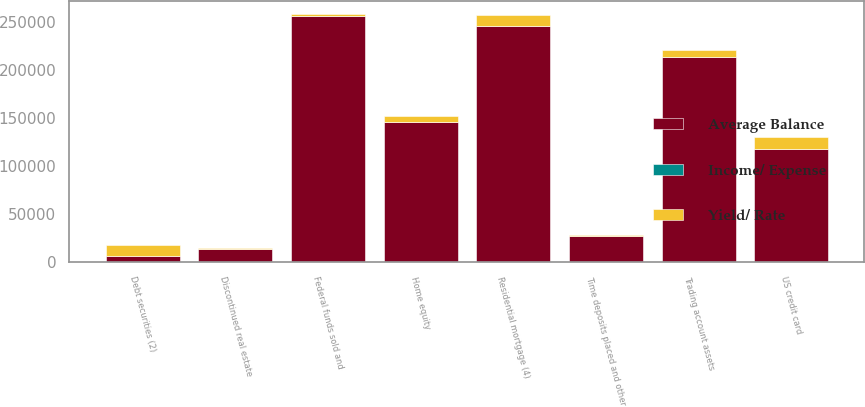Convert chart to OTSL. <chart><loc_0><loc_0><loc_500><loc_500><stacked_bar_chart><ecel><fcel>Time deposits placed and other<fcel>Federal funds sold and<fcel>Trading account assets<fcel>Debt securities (2)<fcel>Residential mortgage (4)<fcel>Home equity<fcel>Discontinued real estate<fcel>US credit card<nl><fcel>Average Balance<fcel>27419<fcel>256943<fcel>213745<fcel>5990<fcel>245727<fcel>145860<fcel>13830<fcel>117962<nl><fcel>Yield/ Rate<fcel>292<fcel>1832<fcel>7050<fcel>11850<fcel>11736<fcel>5990<fcel>527<fcel>12644<nl><fcel>Income/ Expense<fcel>1.06<fcel>0.71<fcel>3.3<fcel>3.66<fcel>4.78<fcel>4.11<fcel>3.81<fcel>10.72<nl></chart> 